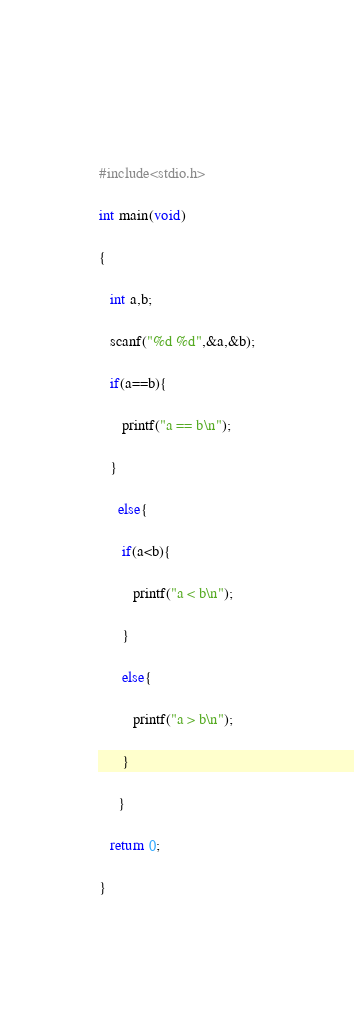Convert code to text. <code><loc_0><loc_0><loc_500><loc_500><_C_>  


#include<stdio.h>

int main(void)

{

   int a,b;

   scanf("%d %d",&a,&b);

   if(a==b){

      printf("a == b\n");

   }

     else{

      if(a<b){

         printf("a < b\n");

      }

      else{

         printf("a > b\n");

      }

     }

   return 0;

}
  </code> 